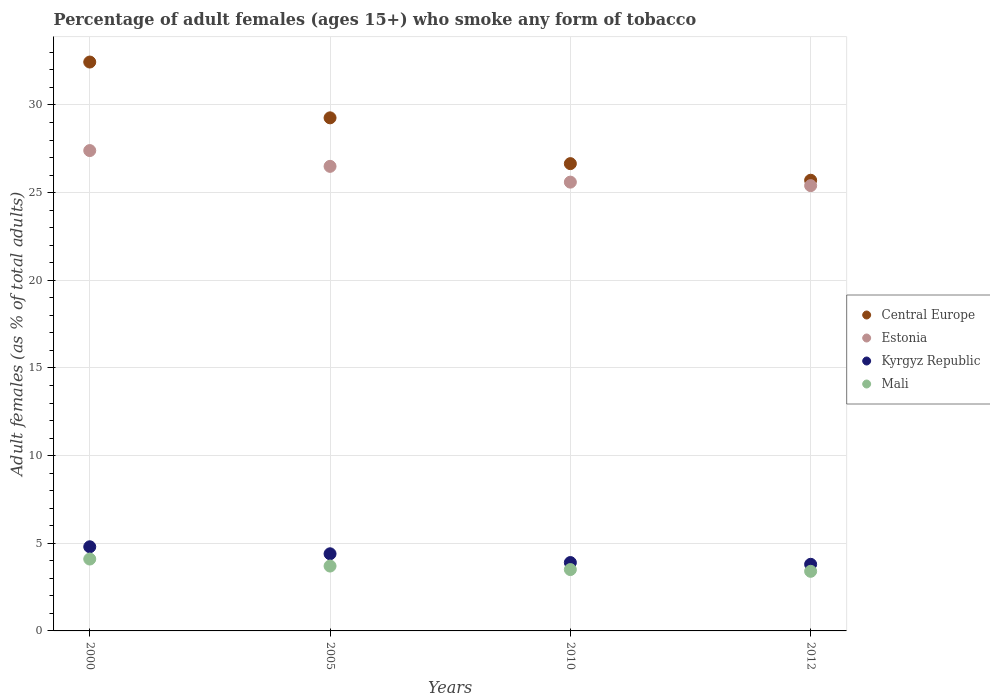Is the number of dotlines equal to the number of legend labels?
Your answer should be very brief. Yes. What is the percentage of adult females who smoke in Kyrgyz Republic in 2005?
Your answer should be compact. 4.4. Across all years, what is the maximum percentage of adult females who smoke in Central Europe?
Make the answer very short. 32.45. What is the difference between the percentage of adult females who smoke in Central Europe in 2000 and that in 2012?
Provide a short and direct response. 6.74. What is the difference between the percentage of adult females who smoke in Kyrgyz Republic in 2000 and the percentage of adult females who smoke in Mali in 2010?
Your answer should be very brief. 1.3. What is the average percentage of adult females who smoke in Estonia per year?
Your response must be concise. 26.23. In the year 2000, what is the difference between the percentage of adult females who smoke in Mali and percentage of adult females who smoke in Estonia?
Make the answer very short. -23.3. In how many years, is the percentage of adult females who smoke in Kyrgyz Republic greater than 10 %?
Ensure brevity in your answer.  0. What is the ratio of the percentage of adult females who smoke in Mali in 2000 to that in 2010?
Provide a short and direct response. 1.17. What is the difference between the highest and the second highest percentage of adult females who smoke in Kyrgyz Republic?
Keep it short and to the point. 0.4. What is the difference between the highest and the lowest percentage of adult females who smoke in Mali?
Offer a terse response. 0.7. In how many years, is the percentage of adult females who smoke in Estonia greater than the average percentage of adult females who smoke in Estonia taken over all years?
Provide a short and direct response. 2. Is the percentage of adult females who smoke in Central Europe strictly less than the percentage of adult females who smoke in Mali over the years?
Provide a succinct answer. No. Does the graph contain any zero values?
Offer a terse response. No. Where does the legend appear in the graph?
Ensure brevity in your answer.  Center right. How many legend labels are there?
Your answer should be very brief. 4. What is the title of the graph?
Your response must be concise. Percentage of adult females (ages 15+) who smoke any form of tobacco. Does "Greenland" appear as one of the legend labels in the graph?
Offer a very short reply. No. What is the label or title of the X-axis?
Provide a short and direct response. Years. What is the label or title of the Y-axis?
Keep it short and to the point. Adult females (as % of total adults). What is the Adult females (as % of total adults) in Central Europe in 2000?
Make the answer very short. 32.45. What is the Adult females (as % of total adults) in Estonia in 2000?
Offer a very short reply. 27.4. What is the Adult females (as % of total adults) in Central Europe in 2005?
Provide a succinct answer. 29.27. What is the Adult females (as % of total adults) of Estonia in 2005?
Provide a succinct answer. 26.5. What is the Adult females (as % of total adults) of Kyrgyz Republic in 2005?
Provide a short and direct response. 4.4. What is the Adult females (as % of total adults) in Central Europe in 2010?
Keep it short and to the point. 26.65. What is the Adult females (as % of total adults) of Estonia in 2010?
Your response must be concise. 25.6. What is the Adult females (as % of total adults) of Kyrgyz Republic in 2010?
Provide a succinct answer. 3.9. What is the Adult females (as % of total adults) in Central Europe in 2012?
Make the answer very short. 25.71. What is the Adult females (as % of total adults) in Estonia in 2012?
Offer a terse response. 25.4. What is the Adult females (as % of total adults) in Mali in 2012?
Provide a succinct answer. 3.4. Across all years, what is the maximum Adult females (as % of total adults) of Central Europe?
Make the answer very short. 32.45. Across all years, what is the maximum Adult females (as % of total adults) in Estonia?
Your answer should be compact. 27.4. Across all years, what is the maximum Adult females (as % of total adults) in Mali?
Provide a short and direct response. 4.1. Across all years, what is the minimum Adult females (as % of total adults) in Central Europe?
Make the answer very short. 25.71. Across all years, what is the minimum Adult females (as % of total adults) in Estonia?
Ensure brevity in your answer.  25.4. What is the total Adult females (as % of total adults) in Central Europe in the graph?
Your answer should be very brief. 114.08. What is the total Adult females (as % of total adults) in Estonia in the graph?
Provide a short and direct response. 104.9. What is the total Adult females (as % of total adults) of Kyrgyz Republic in the graph?
Offer a very short reply. 16.9. What is the total Adult females (as % of total adults) in Mali in the graph?
Provide a short and direct response. 14.7. What is the difference between the Adult females (as % of total adults) in Central Europe in 2000 and that in 2005?
Keep it short and to the point. 3.18. What is the difference between the Adult females (as % of total adults) in Estonia in 2000 and that in 2005?
Give a very brief answer. 0.9. What is the difference between the Adult females (as % of total adults) of Central Europe in 2000 and that in 2010?
Provide a short and direct response. 5.8. What is the difference between the Adult females (as % of total adults) of Estonia in 2000 and that in 2010?
Provide a succinct answer. 1.8. What is the difference between the Adult females (as % of total adults) in Kyrgyz Republic in 2000 and that in 2010?
Make the answer very short. 0.9. What is the difference between the Adult females (as % of total adults) of Central Europe in 2000 and that in 2012?
Offer a terse response. 6.74. What is the difference between the Adult females (as % of total adults) in Estonia in 2000 and that in 2012?
Give a very brief answer. 2. What is the difference between the Adult females (as % of total adults) in Central Europe in 2005 and that in 2010?
Keep it short and to the point. 2.61. What is the difference between the Adult females (as % of total adults) in Estonia in 2005 and that in 2010?
Make the answer very short. 0.9. What is the difference between the Adult females (as % of total adults) of Mali in 2005 and that in 2010?
Provide a short and direct response. 0.2. What is the difference between the Adult females (as % of total adults) of Central Europe in 2005 and that in 2012?
Ensure brevity in your answer.  3.56. What is the difference between the Adult females (as % of total adults) of Estonia in 2005 and that in 2012?
Your response must be concise. 1.1. What is the difference between the Adult females (as % of total adults) in Central Europe in 2010 and that in 2012?
Make the answer very short. 0.95. What is the difference between the Adult females (as % of total adults) in Estonia in 2010 and that in 2012?
Your answer should be compact. 0.2. What is the difference between the Adult females (as % of total adults) in Central Europe in 2000 and the Adult females (as % of total adults) in Estonia in 2005?
Your answer should be very brief. 5.95. What is the difference between the Adult females (as % of total adults) of Central Europe in 2000 and the Adult females (as % of total adults) of Kyrgyz Republic in 2005?
Provide a short and direct response. 28.05. What is the difference between the Adult females (as % of total adults) of Central Europe in 2000 and the Adult females (as % of total adults) of Mali in 2005?
Provide a succinct answer. 28.75. What is the difference between the Adult females (as % of total adults) in Estonia in 2000 and the Adult females (as % of total adults) in Mali in 2005?
Give a very brief answer. 23.7. What is the difference between the Adult females (as % of total adults) in Kyrgyz Republic in 2000 and the Adult females (as % of total adults) in Mali in 2005?
Your answer should be compact. 1.1. What is the difference between the Adult females (as % of total adults) of Central Europe in 2000 and the Adult females (as % of total adults) of Estonia in 2010?
Provide a short and direct response. 6.85. What is the difference between the Adult females (as % of total adults) of Central Europe in 2000 and the Adult females (as % of total adults) of Kyrgyz Republic in 2010?
Offer a very short reply. 28.55. What is the difference between the Adult females (as % of total adults) in Central Europe in 2000 and the Adult females (as % of total adults) in Mali in 2010?
Your answer should be very brief. 28.95. What is the difference between the Adult females (as % of total adults) of Estonia in 2000 and the Adult females (as % of total adults) of Kyrgyz Republic in 2010?
Offer a very short reply. 23.5. What is the difference between the Adult females (as % of total adults) in Estonia in 2000 and the Adult females (as % of total adults) in Mali in 2010?
Give a very brief answer. 23.9. What is the difference between the Adult females (as % of total adults) in Kyrgyz Republic in 2000 and the Adult females (as % of total adults) in Mali in 2010?
Offer a very short reply. 1.3. What is the difference between the Adult females (as % of total adults) in Central Europe in 2000 and the Adult females (as % of total adults) in Estonia in 2012?
Offer a very short reply. 7.05. What is the difference between the Adult females (as % of total adults) in Central Europe in 2000 and the Adult females (as % of total adults) in Kyrgyz Republic in 2012?
Offer a terse response. 28.65. What is the difference between the Adult females (as % of total adults) of Central Europe in 2000 and the Adult females (as % of total adults) of Mali in 2012?
Offer a very short reply. 29.05. What is the difference between the Adult females (as % of total adults) of Estonia in 2000 and the Adult females (as % of total adults) of Kyrgyz Republic in 2012?
Ensure brevity in your answer.  23.6. What is the difference between the Adult females (as % of total adults) of Central Europe in 2005 and the Adult females (as % of total adults) of Estonia in 2010?
Provide a short and direct response. 3.67. What is the difference between the Adult females (as % of total adults) in Central Europe in 2005 and the Adult females (as % of total adults) in Kyrgyz Republic in 2010?
Ensure brevity in your answer.  25.37. What is the difference between the Adult females (as % of total adults) in Central Europe in 2005 and the Adult females (as % of total adults) in Mali in 2010?
Provide a succinct answer. 25.77. What is the difference between the Adult females (as % of total adults) of Estonia in 2005 and the Adult females (as % of total adults) of Kyrgyz Republic in 2010?
Keep it short and to the point. 22.6. What is the difference between the Adult females (as % of total adults) of Central Europe in 2005 and the Adult females (as % of total adults) of Estonia in 2012?
Provide a short and direct response. 3.87. What is the difference between the Adult females (as % of total adults) in Central Europe in 2005 and the Adult females (as % of total adults) in Kyrgyz Republic in 2012?
Ensure brevity in your answer.  25.47. What is the difference between the Adult females (as % of total adults) of Central Europe in 2005 and the Adult females (as % of total adults) of Mali in 2012?
Provide a succinct answer. 25.87. What is the difference between the Adult females (as % of total adults) of Estonia in 2005 and the Adult females (as % of total adults) of Kyrgyz Republic in 2012?
Ensure brevity in your answer.  22.7. What is the difference between the Adult females (as % of total adults) of Estonia in 2005 and the Adult females (as % of total adults) of Mali in 2012?
Ensure brevity in your answer.  23.1. What is the difference between the Adult females (as % of total adults) of Central Europe in 2010 and the Adult females (as % of total adults) of Estonia in 2012?
Offer a terse response. 1.25. What is the difference between the Adult females (as % of total adults) of Central Europe in 2010 and the Adult females (as % of total adults) of Kyrgyz Republic in 2012?
Your answer should be very brief. 22.86. What is the difference between the Adult females (as % of total adults) in Central Europe in 2010 and the Adult females (as % of total adults) in Mali in 2012?
Your answer should be very brief. 23.25. What is the difference between the Adult females (as % of total adults) in Estonia in 2010 and the Adult females (as % of total adults) in Kyrgyz Republic in 2012?
Your response must be concise. 21.8. What is the difference between the Adult females (as % of total adults) of Estonia in 2010 and the Adult females (as % of total adults) of Mali in 2012?
Your answer should be very brief. 22.2. What is the average Adult females (as % of total adults) in Central Europe per year?
Make the answer very short. 28.52. What is the average Adult females (as % of total adults) in Estonia per year?
Your answer should be compact. 26.23. What is the average Adult females (as % of total adults) of Kyrgyz Republic per year?
Your response must be concise. 4.22. What is the average Adult females (as % of total adults) in Mali per year?
Your answer should be very brief. 3.67. In the year 2000, what is the difference between the Adult females (as % of total adults) in Central Europe and Adult females (as % of total adults) in Estonia?
Your answer should be very brief. 5.05. In the year 2000, what is the difference between the Adult females (as % of total adults) in Central Europe and Adult females (as % of total adults) in Kyrgyz Republic?
Make the answer very short. 27.65. In the year 2000, what is the difference between the Adult females (as % of total adults) of Central Europe and Adult females (as % of total adults) of Mali?
Keep it short and to the point. 28.35. In the year 2000, what is the difference between the Adult females (as % of total adults) in Estonia and Adult females (as % of total adults) in Kyrgyz Republic?
Make the answer very short. 22.6. In the year 2000, what is the difference between the Adult females (as % of total adults) of Estonia and Adult females (as % of total adults) of Mali?
Offer a terse response. 23.3. In the year 2000, what is the difference between the Adult females (as % of total adults) of Kyrgyz Republic and Adult females (as % of total adults) of Mali?
Provide a succinct answer. 0.7. In the year 2005, what is the difference between the Adult females (as % of total adults) of Central Europe and Adult females (as % of total adults) of Estonia?
Your answer should be very brief. 2.77. In the year 2005, what is the difference between the Adult females (as % of total adults) of Central Europe and Adult females (as % of total adults) of Kyrgyz Republic?
Offer a terse response. 24.87. In the year 2005, what is the difference between the Adult females (as % of total adults) in Central Europe and Adult females (as % of total adults) in Mali?
Provide a short and direct response. 25.57. In the year 2005, what is the difference between the Adult females (as % of total adults) in Estonia and Adult females (as % of total adults) in Kyrgyz Republic?
Ensure brevity in your answer.  22.1. In the year 2005, what is the difference between the Adult females (as % of total adults) of Estonia and Adult females (as % of total adults) of Mali?
Your answer should be compact. 22.8. In the year 2010, what is the difference between the Adult females (as % of total adults) in Central Europe and Adult females (as % of total adults) in Estonia?
Offer a very short reply. 1.05. In the year 2010, what is the difference between the Adult females (as % of total adults) in Central Europe and Adult females (as % of total adults) in Kyrgyz Republic?
Your response must be concise. 22.75. In the year 2010, what is the difference between the Adult females (as % of total adults) in Central Europe and Adult females (as % of total adults) in Mali?
Your response must be concise. 23.16. In the year 2010, what is the difference between the Adult females (as % of total adults) in Estonia and Adult females (as % of total adults) in Kyrgyz Republic?
Offer a terse response. 21.7. In the year 2010, what is the difference between the Adult females (as % of total adults) of Estonia and Adult females (as % of total adults) of Mali?
Keep it short and to the point. 22.1. In the year 2012, what is the difference between the Adult females (as % of total adults) of Central Europe and Adult females (as % of total adults) of Estonia?
Provide a short and direct response. 0.31. In the year 2012, what is the difference between the Adult females (as % of total adults) of Central Europe and Adult females (as % of total adults) of Kyrgyz Republic?
Provide a short and direct response. 21.91. In the year 2012, what is the difference between the Adult females (as % of total adults) of Central Europe and Adult females (as % of total adults) of Mali?
Make the answer very short. 22.31. In the year 2012, what is the difference between the Adult females (as % of total adults) of Estonia and Adult females (as % of total adults) of Kyrgyz Republic?
Make the answer very short. 21.6. In the year 2012, what is the difference between the Adult females (as % of total adults) in Kyrgyz Republic and Adult females (as % of total adults) in Mali?
Your answer should be compact. 0.4. What is the ratio of the Adult females (as % of total adults) in Central Europe in 2000 to that in 2005?
Your response must be concise. 1.11. What is the ratio of the Adult females (as % of total adults) in Estonia in 2000 to that in 2005?
Your response must be concise. 1.03. What is the ratio of the Adult females (as % of total adults) of Kyrgyz Republic in 2000 to that in 2005?
Your response must be concise. 1.09. What is the ratio of the Adult females (as % of total adults) in Mali in 2000 to that in 2005?
Your response must be concise. 1.11. What is the ratio of the Adult females (as % of total adults) in Central Europe in 2000 to that in 2010?
Your answer should be very brief. 1.22. What is the ratio of the Adult females (as % of total adults) in Estonia in 2000 to that in 2010?
Make the answer very short. 1.07. What is the ratio of the Adult females (as % of total adults) in Kyrgyz Republic in 2000 to that in 2010?
Give a very brief answer. 1.23. What is the ratio of the Adult females (as % of total adults) in Mali in 2000 to that in 2010?
Provide a short and direct response. 1.17. What is the ratio of the Adult females (as % of total adults) in Central Europe in 2000 to that in 2012?
Your answer should be very brief. 1.26. What is the ratio of the Adult females (as % of total adults) of Estonia in 2000 to that in 2012?
Keep it short and to the point. 1.08. What is the ratio of the Adult females (as % of total adults) in Kyrgyz Republic in 2000 to that in 2012?
Your response must be concise. 1.26. What is the ratio of the Adult females (as % of total adults) in Mali in 2000 to that in 2012?
Provide a succinct answer. 1.21. What is the ratio of the Adult females (as % of total adults) in Central Europe in 2005 to that in 2010?
Your response must be concise. 1.1. What is the ratio of the Adult females (as % of total adults) in Estonia in 2005 to that in 2010?
Offer a very short reply. 1.04. What is the ratio of the Adult females (as % of total adults) in Kyrgyz Republic in 2005 to that in 2010?
Your answer should be compact. 1.13. What is the ratio of the Adult females (as % of total adults) in Mali in 2005 to that in 2010?
Ensure brevity in your answer.  1.06. What is the ratio of the Adult females (as % of total adults) in Central Europe in 2005 to that in 2012?
Offer a terse response. 1.14. What is the ratio of the Adult females (as % of total adults) in Estonia in 2005 to that in 2012?
Give a very brief answer. 1.04. What is the ratio of the Adult females (as % of total adults) in Kyrgyz Republic in 2005 to that in 2012?
Your answer should be very brief. 1.16. What is the ratio of the Adult females (as % of total adults) in Mali in 2005 to that in 2012?
Your answer should be compact. 1.09. What is the ratio of the Adult females (as % of total adults) of Central Europe in 2010 to that in 2012?
Provide a succinct answer. 1.04. What is the ratio of the Adult females (as % of total adults) in Estonia in 2010 to that in 2012?
Provide a short and direct response. 1.01. What is the ratio of the Adult females (as % of total adults) of Kyrgyz Republic in 2010 to that in 2012?
Provide a short and direct response. 1.03. What is the ratio of the Adult females (as % of total adults) in Mali in 2010 to that in 2012?
Ensure brevity in your answer.  1.03. What is the difference between the highest and the second highest Adult females (as % of total adults) in Central Europe?
Offer a terse response. 3.18. What is the difference between the highest and the second highest Adult females (as % of total adults) of Estonia?
Give a very brief answer. 0.9. What is the difference between the highest and the second highest Adult females (as % of total adults) of Kyrgyz Republic?
Give a very brief answer. 0.4. What is the difference between the highest and the lowest Adult females (as % of total adults) of Central Europe?
Keep it short and to the point. 6.74. What is the difference between the highest and the lowest Adult females (as % of total adults) in Mali?
Ensure brevity in your answer.  0.7. 